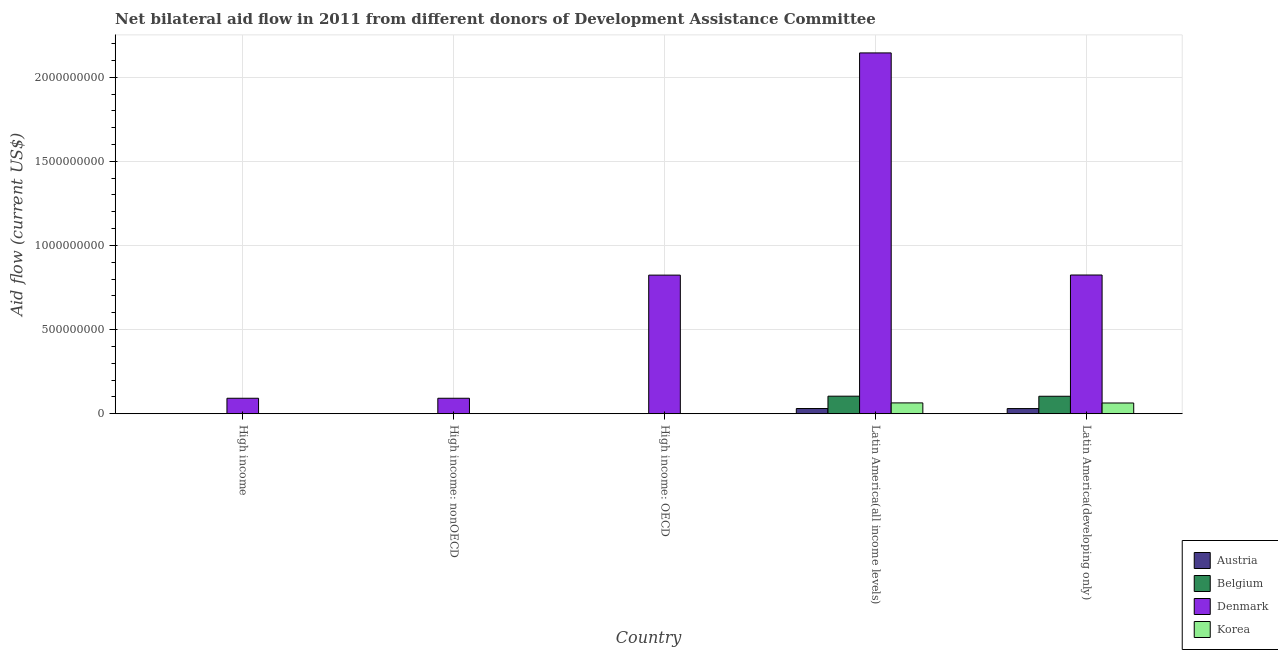How many different coloured bars are there?
Give a very brief answer. 4. Are the number of bars on each tick of the X-axis equal?
Ensure brevity in your answer.  Yes. How many bars are there on the 1st tick from the left?
Your answer should be compact. 4. How many bars are there on the 1st tick from the right?
Make the answer very short. 4. What is the label of the 3rd group of bars from the left?
Your answer should be very brief. High income: OECD. What is the amount of aid given by denmark in High income: nonOECD?
Offer a very short reply. 9.20e+07. Across all countries, what is the maximum amount of aid given by austria?
Ensure brevity in your answer.  3.10e+07. Across all countries, what is the minimum amount of aid given by austria?
Offer a very short reply. 10000. In which country was the amount of aid given by korea maximum?
Provide a short and direct response. Latin America(all income levels). In which country was the amount of aid given by denmark minimum?
Ensure brevity in your answer.  High income. What is the total amount of aid given by belgium in the graph?
Offer a terse response. 2.09e+08. What is the difference between the amount of aid given by denmark in Latin America(all income levels) and that in Latin America(developing only)?
Provide a short and direct response. 1.32e+09. What is the difference between the amount of aid given by denmark in High income: nonOECD and the amount of aid given by belgium in High income?
Offer a very short reply. 9.14e+07. What is the average amount of aid given by denmark per country?
Ensure brevity in your answer.  7.95e+08. What is the difference between the amount of aid given by austria and amount of aid given by belgium in High income: nonOECD?
Make the answer very short. -2.20e+05. In how many countries, is the amount of aid given by denmark greater than 300000000 US$?
Give a very brief answer. 3. What is the ratio of the amount of aid given by austria in High income to that in Latin America(all income levels)?
Offer a very short reply. 0.01. Is the difference between the amount of aid given by belgium in High income and High income: nonOECD greater than the difference between the amount of aid given by denmark in High income and High income: nonOECD?
Make the answer very short. Yes. What is the difference between the highest and the second highest amount of aid given by austria?
Ensure brevity in your answer.  2.30e+05. What is the difference between the highest and the lowest amount of aid given by denmark?
Give a very brief answer. 2.05e+09. In how many countries, is the amount of aid given by denmark greater than the average amount of aid given by denmark taken over all countries?
Give a very brief answer. 3. Is it the case that in every country, the sum of the amount of aid given by denmark and amount of aid given by belgium is greater than the sum of amount of aid given by korea and amount of aid given by austria?
Ensure brevity in your answer.  No. What does the 2nd bar from the left in High income represents?
Offer a very short reply. Belgium. What does the 2nd bar from the right in Latin America(developing only) represents?
Provide a succinct answer. Denmark. Is it the case that in every country, the sum of the amount of aid given by austria and amount of aid given by belgium is greater than the amount of aid given by denmark?
Ensure brevity in your answer.  No. How many countries are there in the graph?
Your response must be concise. 5. What is the difference between two consecutive major ticks on the Y-axis?
Keep it short and to the point. 5.00e+08. Are the values on the major ticks of Y-axis written in scientific E-notation?
Offer a very short reply. No. Does the graph contain any zero values?
Ensure brevity in your answer.  No. Does the graph contain grids?
Provide a succinct answer. Yes. Where does the legend appear in the graph?
Your answer should be very brief. Bottom right. How are the legend labels stacked?
Your answer should be very brief. Vertical. What is the title of the graph?
Your answer should be compact. Net bilateral aid flow in 2011 from different donors of Development Assistance Committee. Does "Permanent crop land" appear as one of the legend labels in the graph?
Provide a succinct answer. No. What is the label or title of the X-axis?
Provide a short and direct response. Country. What is the Aid flow (current US$) of Belgium in High income?
Ensure brevity in your answer.  6.50e+05. What is the Aid flow (current US$) of Denmark in High income?
Ensure brevity in your answer.  9.20e+07. What is the Aid flow (current US$) in Korea in High income?
Offer a very short reply. 8.10e+05. What is the Aid flow (current US$) of Austria in High income: nonOECD?
Your response must be concise. 10000. What is the Aid flow (current US$) in Denmark in High income: nonOECD?
Your answer should be compact. 9.20e+07. What is the Aid flow (current US$) in Austria in High income: OECD?
Your response must be concise. 2.30e+05. What is the Aid flow (current US$) of Belgium in High income: OECD?
Your answer should be compact. 4.20e+05. What is the Aid flow (current US$) of Denmark in High income: OECD?
Provide a succinct answer. 8.24e+08. What is the Aid flow (current US$) in Austria in Latin America(all income levels)?
Your response must be concise. 3.10e+07. What is the Aid flow (current US$) in Belgium in Latin America(all income levels)?
Your answer should be very brief. 1.04e+08. What is the Aid flow (current US$) of Denmark in Latin America(all income levels)?
Give a very brief answer. 2.14e+09. What is the Aid flow (current US$) in Korea in Latin America(all income levels)?
Your response must be concise. 6.44e+07. What is the Aid flow (current US$) of Austria in Latin America(developing only)?
Offer a terse response. 3.07e+07. What is the Aid flow (current US$) in Belgium in Latin America(developing only)?
Your answer should be compact. 1.04e+08. What is the Aid flow (current US$) in Denmark in Latin America(developing only)?
Offer a terse response. 8.24e+08. What is the Aid flow (current US$) in Korea in Latin America(developing only)?
Keep it short and to the point. 6.39e+07. Across all countries, what is the maximum Aid flow (current US$) in Austria?
Provide a succinct answer. 3.10e+07. Across all countries, what is the maximum Aid flow (current US$) in Belgium?
Ensure brevity in your answer.  1.04e+08. Across all countries, what is the maximum Aid flow (current US$) in Denmark?
Your answer should be very brief. 2.14e+09. Across all countries, what is the maximum Aid flow (current US$) in Korea?
Your response must be concise. 6.44e+07. Across all countries, what is the minimum Aid flow (current US$) in Austria?
Provide a succinct answer. 10000. Across all countries, what is the minimum Aid flow (current US$) of Denmark?
Keep it short and to the point. 9.20e+07. Across all countries, what is the minimum Aid flow (current US$) in Korea?
Provide a succinct answer. 2.10e+05. What is the total Aid flow (current US$) of Austria in the graph?
Make the answer very short. 6.22e+07. What is the total Aid flow (current US$) in Belgium in the graph?
Your answer should be very brief. 2.09e+08. What is the total Aid flow (current US$) of Denmark in the graph?
Provide a short and direct response. 3.98e+09. What is the total Aid flow (current US$) of Korea in the graph?
Ensure brevity in your answer.  1.30e+08. What is the difference between the Aid flow (current US$) of Austria in High income and that in High income: nonOECD?
Your answer should be compact. 2.30e+05. What is the difference between the Aid flow (current US$) of Belgium in High income and that in High income: nonOECD?
Make the answer very short. 4.20e+05. What is the difference between the Aid flow (current US$) in Korea in High income and that in High income: nonOECD?
Offer a terse response. 2.10e+05. What is the difference between the Aid flow (current US$) of Denmark in High income and that in High income: OECD?
Your answer should be very brief. -7.32e+08. What is the difference between the Aid flow (current US$) of Austria in High income and that in Latin America(all income levels)?
Provide a short and direct response. -3.07e+07. What is the difference between the Aid flow (current US$) in Belgium in High income and that in Latin America(all income levels)?
Give a very brief answer. -1.04e+08. What is the difference between the Aid flow (current US$) of Denmark in High income and that in Latin America(all income levels)?
Your answer should be very brief. -2.05e+09. What is the difference between the Aid flow (current US$) in Korea in High income and that in Latin America(all income levels)?
Offer a very short reply. -6.36e+07. What is the difference between the Aid flow (current US$) in Austria in High income and that in Latin America(developing only)?
Make the answer very short. -3.05e+07. What is the difference between the Aid flow (current US$) of Belgium in High income and that in Latin America(developing only)?
Make the answer very short. -1.03e+08. What is the difference between the Aid flow (current US$) of Denmark in High income and that in Latin America(developing only)?
Offer a terse response. -7.32e+08. What is the difference between the Aid flow (current US$) in Korea in High income and that in Latin America(developing only)?
Give a very brief answer. -6.31e+07. What is the difference between the Aid flow (current US$) in Belgium in High income: nonOECD and that in High income: OECD?
Provide a succinct answer. -1.90e+05. What is the difference between the Aid flow (current US$) in Denmark in High income: nonOECD and that in High income: OECD?
Ensure brevity in your answer.  -7.32e+08. What is the difference between the Aid flow (current US$) of Korea in High income: nonOECD and that in High income: OECD?
Make the answer very short. 3.90e+05. What is the difference between the Aid flow (current US$) of Austria in High income: nonOECD and that in Latin America(all income levels)?
Your response must be concise. -3.10e+07. What is the difference between the Aid flow (current US$) of Belgium in High income: nonOECD and that in Latin America(all income levels)?
Your answer should be very brief. -1.04e+08. What is the difference between the Aid flow (current US$) in Denmark in High income: nonOECD and that in Latin America(all income levels)?
Your answer should be compact. -2.05e+09. What is the difference between the Aid flow (current US$) in Korea in High income: nonOECD and that in Latin America(all income levels)?
Give a very brief answer. -6.38e+07. What is the difference between the Aid flow (current US$) in Austria in High income: nonOECD and that in Latin America(developing only)?
Provide a succinct answer. -3.07e+07. What is the difference between the Aid flow (current US$) of Belgium in High income: nonOECD and that in Latin America(developing only)?
Give a very brief answer. -1.04e+08. What is the difference between the Aid flow (current US$) of Denmark in High income: nonOECD and that in Latin America(developing only)?
Provide a succinct answer. -7.32e+08. What is the difference between the Aid flow (current US$) of Korea in High income: nonOECD and that in Latin America(developing only)?
Your response must be concise. -6.33e+07. What is the difference between the Aid flow (current US$) in Austria in High income: OECD and that in Latin America(all income levels)?
Offer a terse response. -3.07e+07. What is the difference between the Aid flow (current US$) in Belgium in High income: OECD and that in Latin America(all income levels)?
Your answer should be compact. -1.04e+08. What is the difference between the Aid flow (current US$) of Denmark in High income: OECD and that in Latin America(all income levels)?
Your response must be concise. -1.32e+09. What is the difference between the Aid flow (current US$) of Korea in High income: OECD and that in Latin America(all income levels)?
Offer a terse response. -6.42e+07. What is the difference between the Aid flow (current US$) in Austria in High income: OECD and that in Latin America(developing only)?
Your answer should be very brief. -3.05e+07. What is the difference between the Aid flow (current US$) in Belgium in High income: OECD and that in Latin America(developing only)?
Provide a succinct answer. -1.03e+08. What is the difference between the Aid flow (current US$) of Denmark in High income: OECD and that in Latin America(developing only)?
Give a very brief answer. -7.10e+05. What is the difference between the Aid flow (current US$) in Korea in High income: OECD and that in Latin America(developing only)?
Provide a succinct answer. -6.37e+07. What is the difference between the Aid flow (current US$) of Denmark in Latin America(all income levels) and that in Latin America(developing only)?
Your answer should be very brief. 1.32e+09. What is the difference between the Aid flow (current US$) in Korea in Latin America(all income levels) and that in Latin America(developing only)?
Ensure brevity in your answer.  5.20e+05. What is the difference between the Aid flow (current US$) in Austria in High income and the Aid flow (current US$) in Denmark in High income: nonOECD?
Provide a succinct answer. -9.18e+07. What is the difference between the Aid flow (current US$) in Austria in High income and the Aid flow (current US$) in Korea in High income: nonOECD?
Keep it short and to the point. -3.60e+05. What is the difference between the Aid flow (current US$) of Belgium in High income and the Aid flow (current US$) of Denmark in High income: nonOECD?
Offer a very short reply. -9.14e+07. What is the difference between the Aid flow (current US$) of Denmark in High income and the Aid flow (current US$) of Korea in High income: nonOECD?
Offer a very short reply. 9.14e+07. What is the difference between the Aid flow (current US$) in Austria in High income and the Aid flow (current US$) in Denmark in High income: OECD?
Ensure brevity in your answer.  -8.24e+08. What is the difference between the Aid flow (current US$) in Belgium in High income and the Aid flow (current US$) in Denmark in High income: OECD?
Your answer should be very brief. -8.23e+08. What is the difference between the Aid flow (current US$) in Belgium in High income and the Aid flow (current US$) in Korea in High income: OECD?
Provide a succinct answer. 4.40e+05. What is the difference between the Aid flow (current US$) of Denmark in High income and the Aid flow (current US$) of Korea in High income: OECD?
Your response must be concise. 9.18e+07. What is the difference between the Aid flow (current US$) in Austria in High income and the Aid flow (current US$) in Belgium in Latin America(all income levels)?
Offer a very short reply. -1.04e+08. What is the difference between the Aid flow (current US$) of Austria in High income and the Aid flow (current US$) of Denmark in Latin America(all income levels)?
Make the answer very short. -2.14e+09. What is the difference between the Aid flow (current US$) in Austria in High income and the Aid flow (current US$) in Korea in Latin America(all income levels)?
Your response must be concise. -6.42e+07. What is the difference between the Aid flow (current US$) of Belgium in High income and the Aid flow (current US$) of Denmark in Latin America(all income levels)?
Your answer should be compact. -2.14e+09. What is the difference between the Aid flow (current US$) in Belgium in High income and the Aid flow (current US$) in Korea in Latin America(all income levels)?
Make the answer very short. -6.37e+07. What is the difference between the Aid flow (current US$) in Denmark in High income and the Aid flow (current US$) in Korea in Latin America(all income levels)?
Provide a succinct answer. 2.76e+07. What is the difference between the Aid flow (current US$) of Austria in High income and the Aid flow (current US$) of Belgium in Latin America(developing only)?
Offer a terse response. -1.04e+08. What is the difference between the Aid flow (current US$) of Austria in High income and the Aid flow (current US$) of Denmark in Latin America(developing only)?
Offer a terse response. -8.24e+08. What is the difference between the Aid flow (current US$) of Austria in High income and the Aid flow (current US$) of Korea in Latin America(developing only)?
Your response must be concise. -6.36e+07. What is the difference between the Aid flow (current US$) of Belgium in High income and the Aid flow (current US$) of Denmark in Latin America(developing only)?
Keep it short and to the point. -8.24e+08. What is the difference between the Aid flow (current US$) in Belgium in High income and the Aid flow (current US$) in Korea in Latin America(developing only)?
Your response must be concise. -6.32e+07. What is the difference between the Aid flow (current US$) in Denmark in High income and the Aid flow (current US$) in Korea in Latin America(developing only)?
Provide a succinct answer. 2.81e+07. What is the difference between the Aid flow (current US$) of Austria in High income: nonOECD and the Aid flow (current US$) of Belgium in High income: OECD?
Your answer should be compact. -4.10e+05. What is the difference between the Aid flow (current US$) of Austria in High income: nonOECD and the Aid flow (current US$) of Denmark in High income: OECD?
Your response must be concise. -8.24e+08. What is the difference between the Aid flow (current US$) of Belgium in High income: nonOECD and the Aid flow (current US$) of Denmark in High income: OECD?
Your answer should be compact. -8.24e+08. What is the difference between the Aid flow (current US$) in Belgium in High income: nonOECD and the Aid flow (current US$) in Korea in High income: OECD?
Your response must be concise. 2.00e+04. What is the difference between the Aid flow (current US$) in Denmark in High income: nonOECD and the Aid flow (current US$) in Korea in High income: OECD?
Provide a succinct answer. 9.18e+07. What is the difference between the Aid flow (current US$) in Austria in High income: nonOECD and the Aid flow (current US$) in Belgium in Latin America(all income levels)?
Your answer should be compact. -1.04e+08. What is the difference between the Aid flow (current US$) in Austria in High income: nonOECD and the Aid flow (current US$) in Denmark in Latin America(all income levels)?
Ensure brevity in your answer.  -2.14e+09. What is the difference between the Aid flow (current US$) of Austria in High income: nonOECD and the Aid flow (current US$) of Korea in Latin America(all income levels)?
Provide a short and direct response. -6.44e+07. What is the difference between the Aid flow (current US$) in Belgium in High income: nonOECD and the Aid flow (current US$) in Denmark in Latin America(all income levels)?
Keep it short and to the point. -2.14e+09. What is the difference between the Aid flow (current US$) of Belgium in High income: nonOECD and the Aid flow (current US$) of Korea in Latin America(all income levels)?
Offer a very short reply. -6.42e+07. What is the difference between the Aid flow (current US$) in Denmark in High income: nonOECD and the Aid flow (current US$) in Korea in Latin America(all income levels)?
Your answer should be very brief. 2.76e+07. What is the difference between the Aid flow (current US$) of Austria in High income: nonOECD and the Aid flow (current US$) of Belgium in Latin America(developing only)?
Make the answer very short. -1.04e+08. What is the difference between the Aid flow (current US$) of Austria in High income: nonOECD and the Aid flow (current US$) of Denmark in Latin America(developing only)?
Keep it short and to the point. -8.24e+08. What is the difference between the Aid flow (current US$) in Austria in High income: nonOECD and the Aid flow (current US$) in Korea in Latin America(developing only)?
Your response must be concise. -6.39e+07. What is the difference between the Aid flow (current US$) of Belgium in High income: nonOECD and the Aid flow (current US$) of Denmark in Latin America(developing only)?
Ensure brevity in your answer.  -8.24e+08. What is the difference between the Aid flow (current US$) in Belgium in High income: nonOECD and the Aid flow (current US$) in Korea in Latin America(developing only)?
Your response must be concise. -6.36e+07. What is the difference between the Aid flow (current US$) in Denmark in High income: nonOECD and the Aid flow (current US$) in Korea in Latin America(developing only)?
Keep it short and to the point. 2.81e+07. What is the difference between the Aid flow (current US$) of Austria in High income: OECD and the Aid flow (current US$) of Belgium in Latin America(all income levels)?
Provide a succinct answer. -1.04e+08. What is the difference between the Aid flow (current US$) in Austria in High income: OECD and the Aid flow (current US$) in Denmark in Latin America(all income levels)?
Ensure brevity in your answer.  -2.14e+09. What is the difference between the Aid flow (current US$) of Austria in High income: OECD and the Aid flow (current US$) of Korea in Latin America(all income levels)?
Give a very brief answer. -6.42e+07. What is the difference between the Aid flow (current US$) of Belgium in High income: OECD and the Aid flow (current US$) of Denmark in Latin America(all income levels)?
Ensure brevity in your answer.  -2.14e+09. What is the difference between the Aid flow (current US$) of Belgium in High income: OECD and the Aid flow (current US$) of Korea in Latin America(all income levels)?
Give a very brief answer. -6.40e+07. What is the difference between the Aid flow (current US$) in Denmark in High income: OECD and the Aid flow (current US$) in Korea in Latin America(all income levels)?
Your answer should be compact. 7.59e+08. What is the difference between the Aid flow (current US$) in Austria in High income: OECD and the Aid flow (current US$) in Belgium in Latin America(developing only)?
Offer a very short reply. -1.04e+08. What is the difference between the Aid flow (current US$) of Austria in High income: OECD and the Aid flow (current US$) of Denmark in Latin America(developing only)?
Offer a terse response. -8.24e+08. What is the difference between the Aid flow (current US$) in Austria in High income: OECD and the Aid flow (current US$) in Korea in Latin America(developing only)?
Your response must be concise. -6.36e+07. What is the difference between the Aid flow (current US$) of Belgium in High income: OECD and the Aid flow (current US$) of Denmark in Latin America(developing only)?
Offer a very short reply. -8.24e+08. What is the difference between the Aid flow (current US$) of Belgium in High income: OECD and the Aid flow (current US$) of Korea in Latin America(developing only)?
Your response must be concise. -6.34e+07. What is the difference between the Aid flow (current US$) in Denmark in High income: OECD and the Aid flow (current US$) in Korea in Latin America(developing only)?
Your answer should be compact. 7.60e+08. What is the difference between the Aid flow (current US$) in Austria in Latin America(all income levels) and the Aid flow (current US$) in Belgium in Latin America(developing only)?
Keep it short and to the point. -7.29e+07. What is the difference between the Aid flow (current US$) in Austria in Latin America(all income levels) and the Aid flow (current US$) in Denmark in Latin America(developing only)?
Provide a short and direct response. -7.94e+08. What is the difference between the Aid flow (current US$) in Austria in Latin America(all income levels) and the Aid flow (current US$) in Korea in Latin America(developing only)?
Your answer should be very brief. -3.29e+07. What is the difference between the Aid flow (current US$) in Belgium in Latin America(all income levels) and the Aid flow (current US$) in Denmark in Latin America(developing only)?
Ensure brevity in your answer.  -7.20e+08. What is the difference between the Aid flow (current US$) in Belgium in Latin America(all income levels) and the Aid flow (current US$) in Korea in Latin America(developing only)?
Keep it short and to the point. 4.04e+07. What is the difference between the Aid flow (current US$) in Denmark in Latin America(all income levels) and the Aid flow (current US$) in Korea in Latin America(developing only)?
Give a very brief answer. 2.08e+09. What is the average Aid flow (current US$) of Austria per country?
Ensure brevity in your answer.  1.24e+07. What is the average Aid flow (current US$) in Belgium per country?
Keep it short and to the point. 4.19e+07. What is the average Aid flow (current US$) of Denmark per country?
Your response must be concise. 7.95e+08. What is the average Aid flow (current US$) of Korea per country?
Provide a succinct answer. 2.60e+07. What is the difference between the Aid flow (current US$) of Austria and Aid flow (current US$) of Belgium in High income?
Give a very brief answer. -4.10e+05. What is the difference between the Aid flow (current US$) of Austria and Aid flow (current US$) of Denmark in High income?
Offer a very short reply. -9.18e+07. What is the difference between the Aid flow (current US$) in Austria and Aid flow (current US$) in Korea in High income?
Offer a terse response. -5.70e+05. What is the difference between the Aid flow (current US$) in Belgium and Aid flow (current US$) in Denmark in High income?
Your answer should be very brief. -9.14e+07. What is the difference between the Aid flow (current US$) in Belgium and Aid flow (current US$) in Korea in High income?
Make the answer very short. -1.60e+05. What is the difference between the Aid flow (current US$) of Denmark and Aid flow (current US$) of Korea in High income?
Your response must be concise. 9.12e+07. What is the difference between the Aid flow (current US$) of Austria and Aid flow (current US$) of Belgium in High income: nonOECD?
Ensure brevity in your answer.  -2.20e+05. What is the difference between the Aid flow (current US$) in Austria and Aid flow (current US$) in Denmark in High income: nonOECD?
Your answer should be compact. -9.20e+07. What is the difference between the Aid flow (current US$) of Austria and Aid flow (current US$) of Korea in High income: nonOECD?
Make the answer very short. -5.90e+05. What is the difference between the Aid flow (current US$) in Belgium and Aid flow (current US$) in Denmark in High income: nonOECD?
Provide a short and direct response. -9.18e+07. What is the difference between the Aid flow (current US$) of Belgium and Aid flow (current US$) of Korea in High income: nonOECD?
Ensure brevity in your answer.  -3.70e+05. What is the difference between the Aid flow (current US$) of Denmark and Aid flow (current US$) of Korea in High income: nonOECD?
Provide a short and direct response. 9.14e+07. What is the difference between the Aid flow (current US$) of Austria and Aid flow (current US$) of Belgium in High income: OECD?
Provide a succinct answer. -1.90e+05. What is the difference between the Aid flow (current US$) of Austria and Aid flow (current US$) of Denmark in High income: OECD?
Your answer should be very brief. -8.24e+08. What is the difference between the Aid flow (current US$) in Belgium and Aid flow (current US$) in Denmark in High income: OECD?
Offer a very short reply. -8.23e+08. What is the difference between the Aid flow (current US$) in Denmark and Aid flow (current US$) in Korea in High income: OECD?
Offer a terse response. 8.24e+08. What is the difference between the Aid flow (current US$) of Austria and Aid flow (current US$) of Belgium in Latin America(all income levels)?
Your answer should be very brief. -7.33e+07. What is the difference between the Aid flow (current US$) of Austria and Aid flow (current US$) of Denmark in Latin America(all income levels)?
Your answer should be very brief. -2.11e+09. What is the difference between the Aid flow (current US$) of Austria and Aid flow (current US$) of Korea in Latin America(all income levels)?
Offer a very short reply. -3.34e+07. What is the difference between the Aid flow (current US$) in Belgium and Aid flow (current US$) in Denmark in Latin America(all income levels)?
Provide a succinct answer. -2.04e+09. What is the difference between the Aid flow (current US$) of Belgium and Aid flow (current US$) of Korea in Latin America(all income levels)?
Provide a short and direct response. 3.99e+07. What is the difference between the Aid flow (current US$) of Denmark and Aid flow (current US$) of Korea in Latin America(all income levels)?
Give a very brief answer. 2.08e+09. What is the difference between the Aid flow (current US$) of Austria and Aid flow (current US$) of Belgium in Latin America(developing only)?
Offer a very short reply. -7.31e+07. What is the difference between the Aid flow (current US$) of Austria and Aid flow (current US$) of Denmark in Latin America(developing only)?
Offer a very short reply. -7.94e+08. What is the difference between the Aid flow (current US$) of Austria and Aid flow (current US$) of Korea in Latin America(developing only)?
Your answer should be compact. -3.31e+07. What is the difference between the Aid flow (current US$) of Belgium and Aid flow (current US$) of Denmark in Latin America(developing only)?
Your response must be concise. -7.21e+08. What is the difference between the Aid flow (current US$) in Belgium and Aid flow (current US$) in Korea in Latin America(developing only)?
Offer a terse response. 4.00e+07. What is the difference between the Aid flow (current US$) in Denmark and Aid flow (current US$) in Korea in Latin America(developing only)?
Your answer should be compact. 7.61e+08. What is the ratio of the Aid flow (current US$) of Austria in High income to that in High income: nonOECD?
Provide a short and direct response. 24. What is the ratio of the Aid flow (current US$) in Belgium in High income to that in High income: nonOECD?
Give a very brief answer. 2.83. What is the ratio of the Aid flow (current US$) of Korea in High income to that in High income: nonOECD?
Make the answer very short. 1.35. What is the ratio of the Aid flow (current US$) in Austria in High income to that in High income: OECD?
Your answer should be compact. 1.04. What is the ratio of the Aid flow (current US$) in Belgium in High income to that in High income: OECD?
Ensure brevity in your answer.  1.55. What is the ratio of the Aid flow (current US$) of Denmark in High income to that in High income: OECD?
Make the answer very short. 0.11. What is the ratio of the Aid flow (current US$) of Korea in High income to that in High income: OECD?
Your answer should be compact. 3.86. What is the ratio of the Aid flow (current US$) of Austria in High income to that in Latin America(all income levels)?
Make the answer very short. 0.01. What is the ratio of the Aid flow (current US$) in Belgium in High income to that in Latin America(all income levels)?
Offer a terse response. 0.01. What is the ratio of the Aid flow (current US$) of Denmark in High income to that in Latin America(all income levels)?
Provide a succinct answer. 0.04. What is the ratio of the Aid flow (current US$) in Korea in High income to that in Latin America(all income levels)?
Provide a short and direct response. 0.01. What is the ratio of the Aid flow (current US$) of Austria in High income to that in Latin America(developing only)?
Provide a short and direct response. 0.01. What is the ratio of the Aid flow (current US$) in Belgium in High income to that in Latin America(developing only)?
Your answer should be compact. 0.01. What is the ratio of the Aid flow (current US$) of Denmark in High income to that in Latin America(developing only)?
Offer a very short reply. 0.11. What is the ratio of the Aid flow (current US$) of Korea in High income to that in Latin America(developing only)?
Make the answer very short. 0.01. What is the ratio of the Aid flow (current US$) of Austria in High income: nonOECD to that in High income: OECD?
Provide a succinct answer. 0.04. What is the ratio of the Aid flow (current US$) of Belgium in High income: nonOECD to that in High income: OECD?
Your answer should be compact. 0.55. What is the ratio of the Aid flow (current US$) in Denmark in High income: nonOECD to that in High income: OECD?
Give a very brief answer. 0.11. What is the ratio of the Aid flow (current US$) of Korea in High income: nonOECD to that in High income: OECD?
Your answer should be compact. 2.86. What is the ratio of the Aid flow (current US$) of Belgium in High income: nonOECD to that in Latin America(all income levels)?
Your response must be concise. 0. What is the ratio of the Aid flow (current US$) of Denmark in High income: nonOECD to that in Latin America(all income levels)?
Keep it short and to the point. 0.04. What is the ratio of the Aid flow (current US$) in Korea in High income: nonOECD to that in Latin America(all income levels)?
Provide a short and direct response. 0.01. What is the ratio of the Aid flow (current US$) of Austria in High income: nonOECD to that in Latin America(developing only)?
Keep it short and to the point. 0. What is the ratio of the Aid flow (current US$) in Belgium in High income: nonOECD to that in Latin America(developing only)?
Offer a very short reply. 0. What is the ratio of the Aid flow (current US$) in Denmark in High income: nonOECD to that in Latin America(developing only)?
Ensure brevity in your answer.  0.11. What is the ratio of the Aid flow (current US$) of Korea in High income: nonOECD to that in Latin America(developing only)?
Give a very brief answer. 0.01. What is the ratio of the Aid flow (current US$) of Austria in High income: OECD to that in Latin America(all income levels)?
Provide a short and direct response. 0.01. What is the ratio of the Aid flow (current US$) of Belgium in High income: OECD to that in Latin America(all income levels)?
Ensure brevity in your answer.  0. What is the ratio of the Aid flow (current US$) of Denmark in High income: OECD to that in Latin America(all income levels)?
Ensure brevity in your answer.  0.38. What is the ratio of the Aid flow (current US$) of Korea in High income: OECD to that in Latin America(all income levels)?
Offer a terse response. 0. What is the ratio of the Aid flow (current US$) of Austria in High income: OECD to that in Latin America(developing only)?
Your answer should be very brief. 0.01. What is the ratio of the Aid flow (current US$) in Belgium in High income: OECD to that in Latin America(developing only)?
Ensure brevity in your answer.  0. What is the ratio of the Aid flow (current US$) of Denmark in High income: OECD to that in Latin America(developing only)?
Provide a short and direct response. 1. What is the ratio of the Aid flow (current US$) in Korea in High income: OECD to that in Latin America(developing only)?
Offer a terse response. 0. What is the ratio of the Aid flow (current US$) of Austria in Latin America(all income levels) to that in Latin America(developing only)?
Keep it short and to the point. 1.01. What is the ratio of the Aid flow (current US$) in Belgium in Latin America(all income levels) to that in Latin America(developing only)?
Offer a terse response. 1. What is the ratio of the Aid flow (current US$) in Denmark in Latin America(all income levels) to that in Latin America(developing only)?
Keep it short and to the point. 2.6. What is the difference between the highest and the second highest Aid flow (current US$) in Belgium?
Provide a short and direct response. 4.70e+05. What is the difference between the highest and the second highest Aid flow (current US$) of Denmark?
Ensure brevity in your answer.  1.32e+09. What is the difference between the highest and the second highest Aid flow (current US$) of Korea?
Give a very brief answer. 5.20e+05. What is the difference between the highest and the lowest Aid flow (current US$) in Austria?
Provide a succinct answer. 3.10e+07. What is the difference between the highest and the lowest Aid flow (current US$) of Belgium?
Your answer should be compact. 1.04e+08. What is the difference between the highest and the lowest Aid flow (current US$) of Denmark?
Keep it short and to the point. 2.05e+09. What is the difference between the highest and the lowest Aid flow (current US$) of Korea?
Your response must be concise. 6.42e+07. 